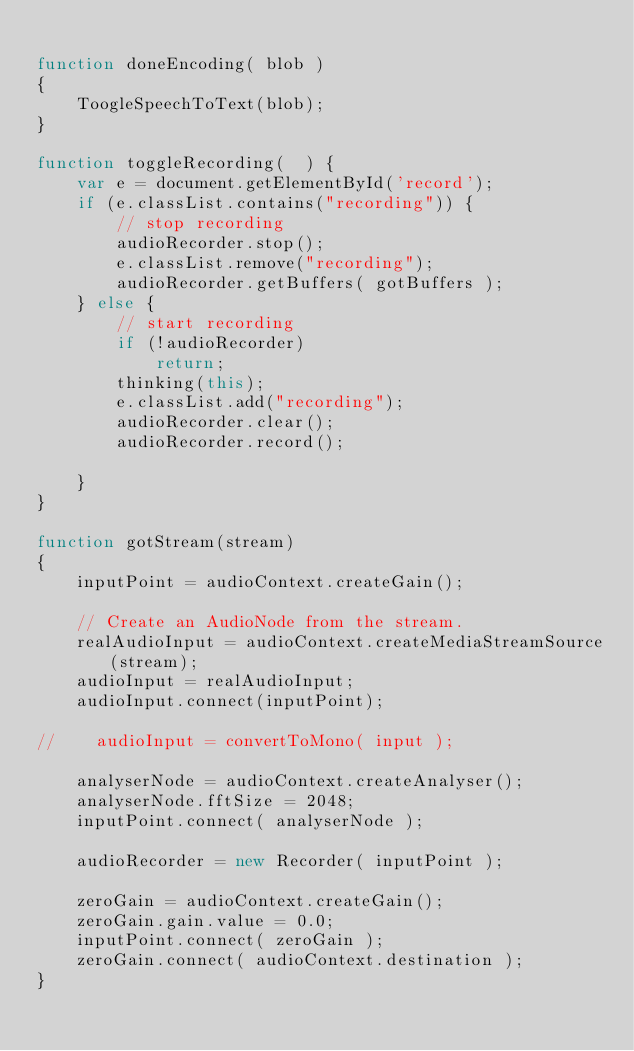Convert code to text. <code><loc_0><loc_0><loc_500><loc_500><_JavaScript_>
function doneEncoding( blob ) 
{
    ToogleSpeechToText(blob);
}

function toggleRecording(  ) {
    var e = document.getElementById('record');
    if (e.classList.contains("recording")) {
        // stop recording
        audioRecorder.stop();
        e.classList.remove("recording");
        audioRecorder.getBuffers( gotBuffers );
    } else {
        // start recording
        if (!audioRecorder)
            return;
        thinking(this);
        e.classList.add("recording");
        audioRecorder.clear();
        audioRecorder.record();

    }
}

function gotStream(stream) 
{
    inputPoint = audioContext.createGain();

    // Create an AudioNode from the stream.
    realAudioInput = audioContext.createMediaStreamSource(stream);
    audioInput = realAudioInput;
    audioInput.connect(inputPoint);

//    audioInput = convertToMono( input );

    analyserNode = audioContext.createAnalyser();
    analyserNode.fftSize = 2048;
    inputPoint.connect( analyserNode );

    audioRecorder = new Recorder( inputPoint );

    zeroGain = audioContext.createGain();
    zeroGain.gain.value = 0.0;
    inputPoint.connect( zeroGain );
    zeroGain.connect( audioContext.destination );
}
</code> 